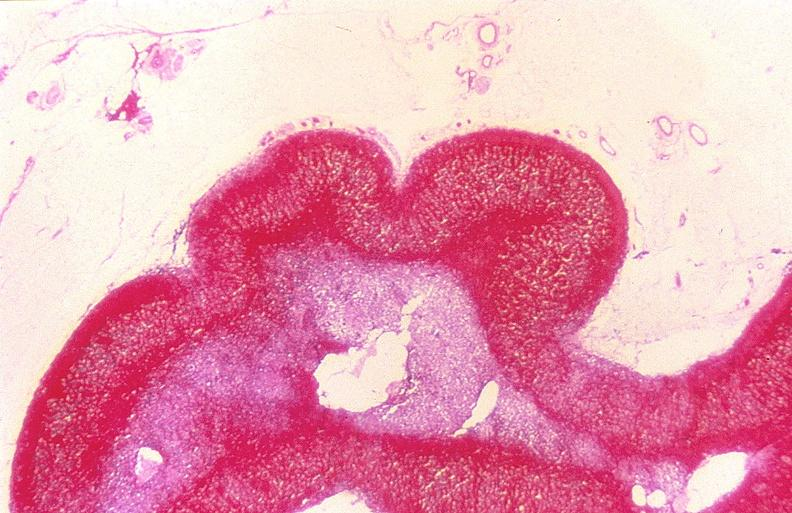what is present?
Answer the question using a single word or phrase. Endocrine 